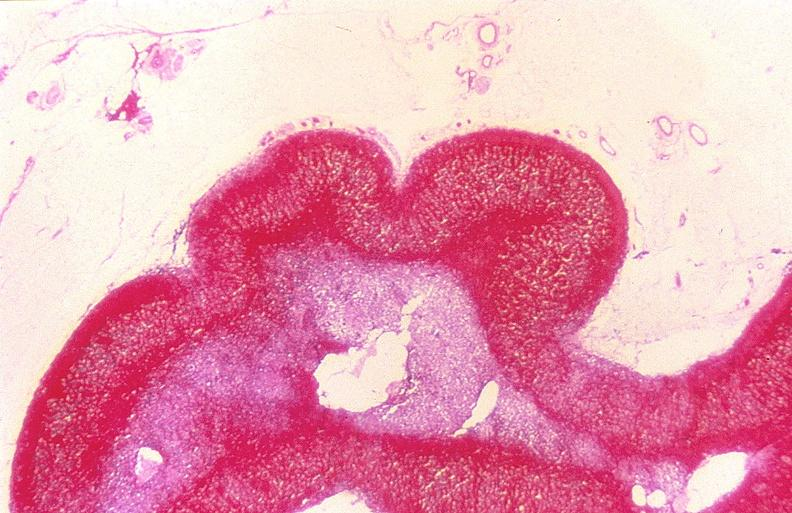what is present?
Answer the question using a single word or phrase. Endocrine 